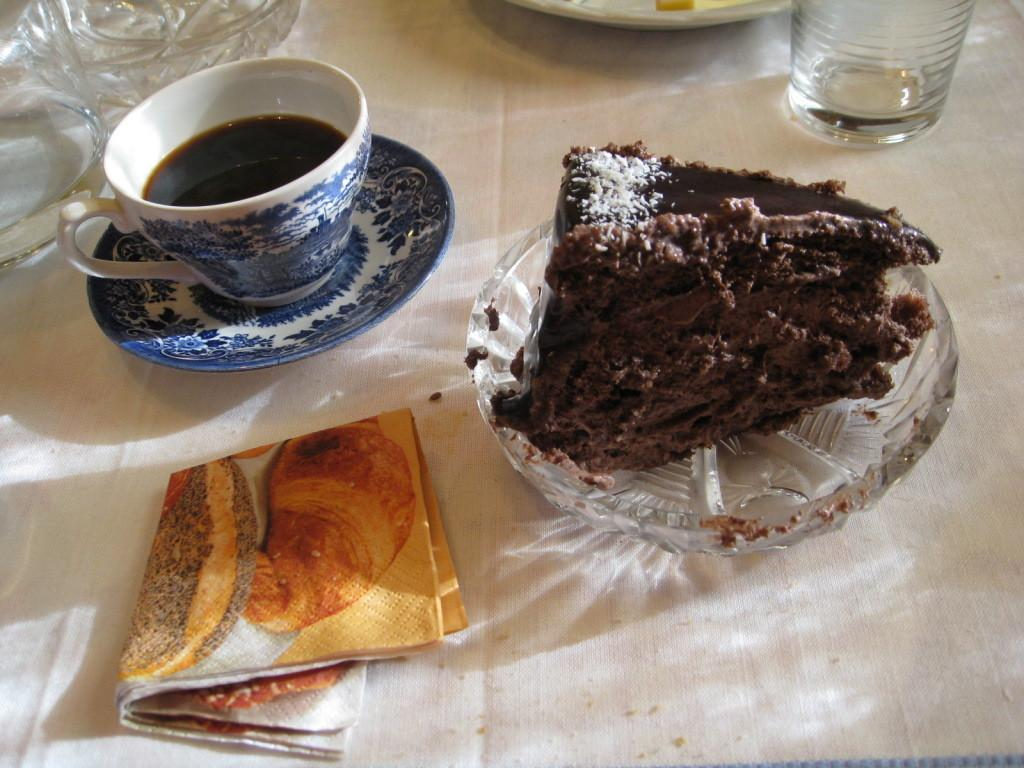What piece of furniture is present in the image? There is a table in the image. What items are placed on the table? There are plates, a cup, a saucer, a glass, napkins, and a cake on the table. How many plates are on the table? The number of plates is not mentioned in the facts, so it cannot be determined. What might be used for cleaning or wiping in the image? Napkins are present on the table for cleaning or wiping. How many bikes are parked near the table in the image? There is no mention of bikes in the image, so it cannot be determined. 